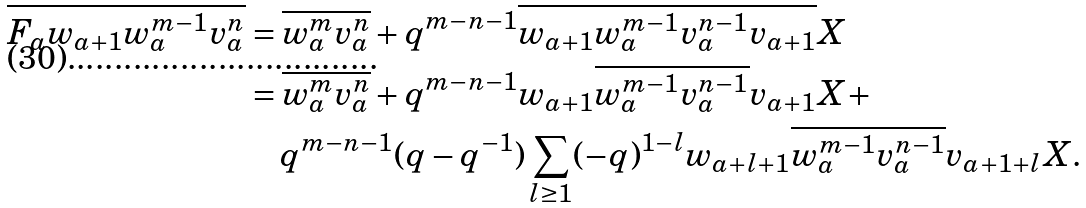<formula> <loc_0><loc_0><loc_500><loc_500>\overline { F _ { a } w _ { a + 1 } w _ { a } ^ { m - 1 } v _ { a } ^ { n } } & = \overline { w _ { a } ^ { m } v _ { a } ^ { n } } + q ^ { m - n - 1 } \overline { w _ { a + 1 } w _ { a } ^ { m - 1 } v _ { a } ^ { n - 1 } v _ { a + 1 } } X \\ & = \overline { w _ { a } ^ { m } v _ { a } ^ { n } } + q ^ { m - n - 1 } w _ { a + 1 } \overline { w _ { a } ^ { m - 1 } v _ { a } ^ { n - 1 } } v _ { a + 1 } X + \\ & \quad q ^ { m - n - 1 } ( q - q ^ { - 1 } ) \sum _ { l \geq 1 } ( - q ) ^ { 1 - l } w _ { a + l + 1 } \overline { w _ { a } ^ { m - 1 } v _ { a } ^ { n - 1 } } v _ { a + 1 + l } X .</formula> 